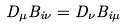Convert formula to latex. <formula><loc_0><loc_0><loc_500><loc_500>D _ { \mu } B _ { i \nu } = D _ { \nu } B _ { i \mu }</formula> 